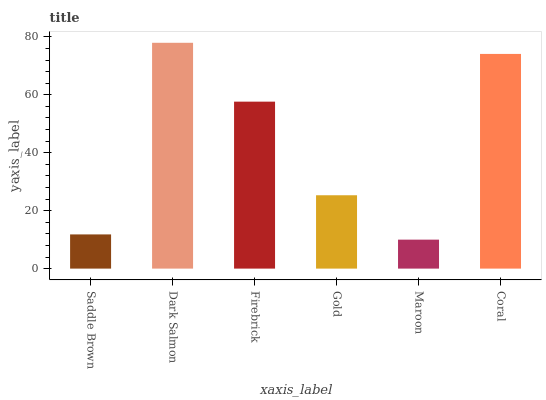Is Maroon the minimum?
Answer yes or no. Yes. Is Dark Salmon the maximum?
Answer yes or no. Yes. Is Firebrick the minimum?
Answer yes or no. No. Is Firebrick the maximum?
Answer yes or no. No. Is Dark Salmon greater than Firebrick?
Answer yes or no. Yes. Is Firebrick less than Dark Salmon?
Answer yes or no. Yes. Is Firebrick greater than Dark Salmon?
Answer yes or no. No. Is Dark Salmon less than Firebrick?
Answer yes or no. No. Is Firebrick the high median?
Answer yes or no. Yes. Is Gold the low median?
Answer yes or no. Yes. Is Saddle Brown the high median?
Answer yes or no. No. Is Coral the low median?
Answer yes or no. No. 